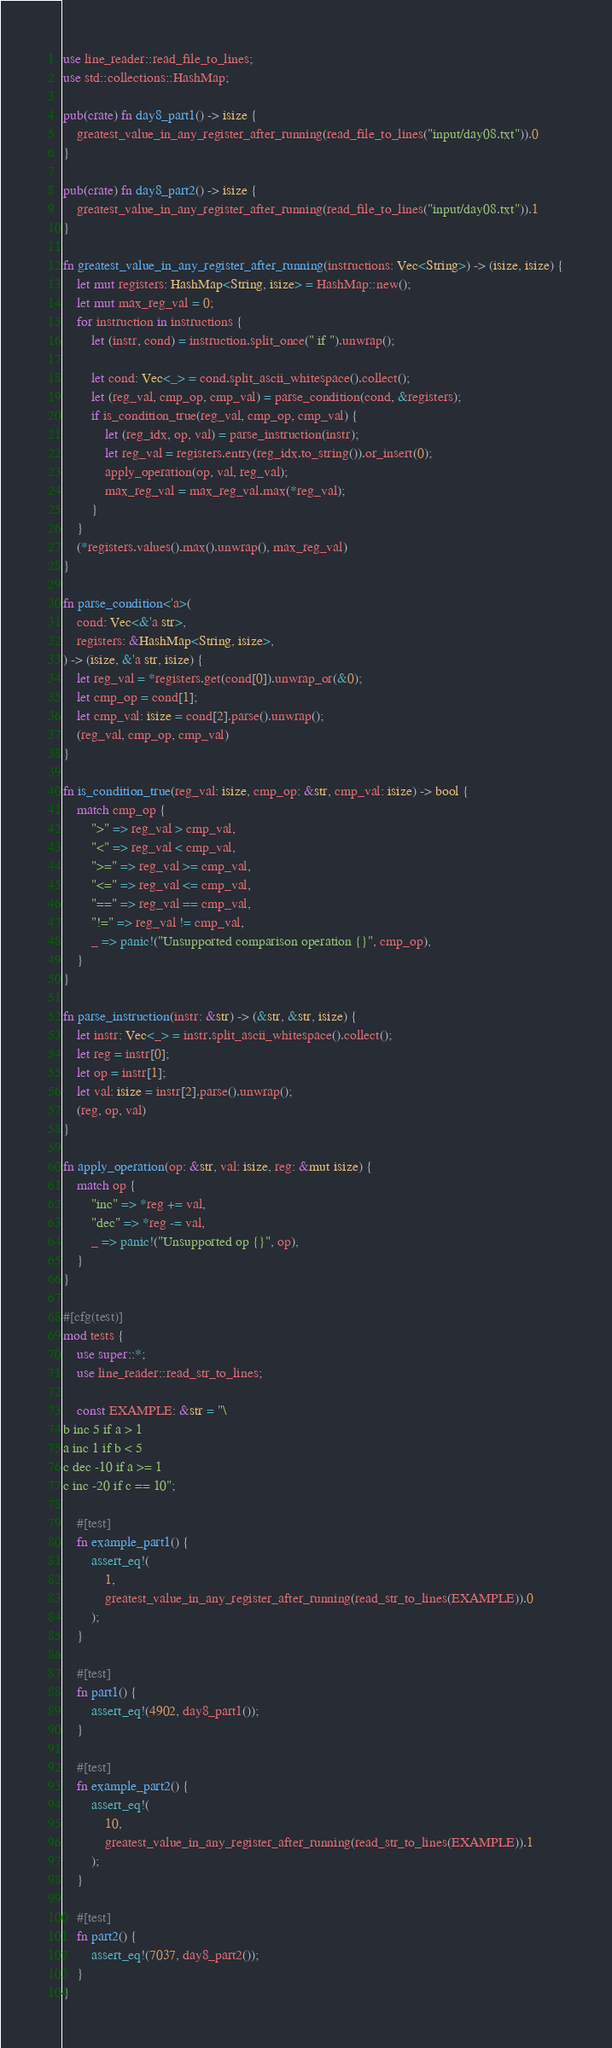Convert code to text. <code><loc_0><loc_0><loc_500><loc_500><_Rust_>use line_reader::read_file_to_lines;
use std::collections::HashMap;

pub(crate) fn day8_part1() -> isize {
    greatest_value_in_any_register_after_running(read_file_to_lines("input/day08.txt")).0
}

pub(crate) fn day8_part2() -> isize {
    greatest_value_in_any_register_after_running(read_file_to_lines("input/day08.txt")).1
}

fn greatest_value_in_any_register_after_running(instructions: Vec<String>) -> (isize, isize) {
    let mut registers: HashMap<String, isize> = HashMap::new();
    let mut max_reg_val = 0;
    for instruction in instructions {
        let (instr, cond) = instruction.split_once(" if ").unwrap();

        let cond: Vec<_> = cond.split_ascii_whitespace().collect();
        let (reg_val, cmp_op, cmp_val) = parse_condition(cond, &registers);
        if is_condition_true(reg_val, cmp_op, cmp_val) {
            let (reg_idx, op, val) = parse_instruction(instr);
            let reg_val = registers.entry(reg_idx.to_string()).or_insert(0);
            apply_operation(op, val, reg_val);
            max_reg_val = max_reg_val.max(*reg_val);
        }
    }
    (*registers.values().max().unwrap(), max_reg_val)
}

fn parse_condition<'a>(
    cond: Vec<&'a str>,
    registers: &HashMap<String, isize>,
) -> (isize, &'a str, isize) {
    let reg_val = *registers.get(cond[0]).unwrap_or(&0);
    let cmp_op = cond[1];
    let cmp_val: isize = cond[2].parse().unwrap();
    (reg_val, cmp_op, cmp_val)
}

fn is_condition_true(reg_val: isize, cmp_op: &str, cmp_val: isize) -> bool {
    match cmp_op {
        ">" => reg_val > cmp_val,
        "<" => reg_val < cmp_val,
        ">=" => reg_val >= cmp_val,
        "<=" => reg_val <= cmp_val,
        "==" => reg_val == cmp_val,
        "!=" => reg_val != cmp_val,
        _ => panic!("Unsupported comparison operation {}", cmp_op),
    }
}

fn parse_instruction(instr: &str) -> (&str, &str, isize) {
    let instr: Vec<_> = instr.split_ascii_whitespace().collect();
    let reg = instr[0];
    let op = instr[1];
    let val: isize = instr[2].parse().unwrap();
    (reg, op, val)
}

fn apply_operation(op: &str, val: isize, reg: &mut isize) {
    match op {
        "inc" => *reg += val,
        "dec" => *reg -= val,
        _ => panic!("Unsupported op {}", op),
    }
}

#[cfg(test)]
mod tests {
    use super::*;
    use line_reader::read_str_to_lines;

    const EXAMPLE: &str = "\
b inc 5 if a > 1
a inc 1 if b < 5
c dec -10 if a >= 1
c inc -20 if c == 10";

    #[test]
    fn example_part1() {
        assert_eq!(
            1,
            greatest_value_in_any_register_after_running(read_str_to_lines(EXAMPLE)).0
        );
    }

    #[test]
    fn part1() {
        assert_eq!(4902, day8_part1());
    }

    #[test]
    fn example_part2() {
        assert_eq!(
            10,
            greatest_value_in_any_register_after_running(read_str_to_lines(EXAMPLE)).1
        );
    }

    #[test]
    fn part2() {
        assert_eq!(7037, day8_part2());
    }
}
</code> 